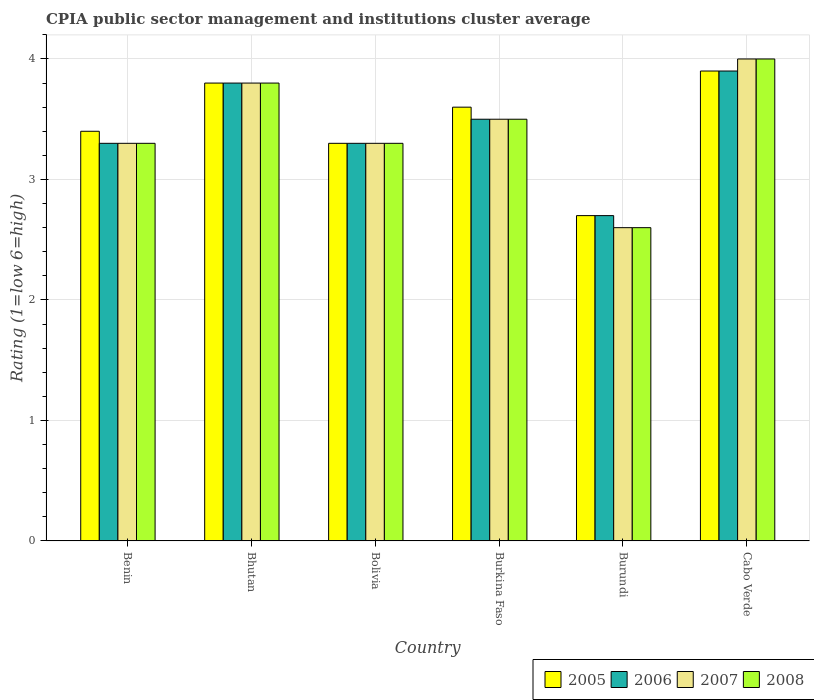How many groups of bars are there?
Provide a succinct answer. 6. Are the number of bars on each tick of the X-axis equal?
Provide a succinct answer. Yes. How many bars are there on the 3rd tick from the right?
Your answer should be compact. 4. What is the label of the 6th group of bars from the left?
Ensure brevity in your answer.  Cabo Verde. In how many cases, is the number of bars for a given country not equal to the number of legend labels?
Provide a short and direct response. 0. What is the CPIA rating in 2005 in Bhutan?
Keep it short and to the point. 3.8. Across all countries, what is the maximum CPIA rating in 2005?
Provide a succinct answer. 3.9. Across all countries, what is the minimum CPIA rating in 2008?
Your answer should be compact. 2.6. In which country was the CPIA rating in 2006 maximum?
Provide a short and direct response. Cabo Verde. In which country was the CPIA rating in 2007 minimum?
Make the answer very short. Burundi. What is the difference between the CPIA rating in 2007 in Burkina Faso and that in Burundi?
Ensure brevity in your answer.  0.9. What is the average CPIA rating in 2006 per country?
Offer a very short reply. 3.42. What is the difference between the CPIA rating of/in 2005 and CPIA rating of/in 2008 in Burundi?
Offer a very short reply. 0.1. In how many countries, is the CPIA rating in 2006 greater than 1.2?
Give a very brief answer. 6. What is the ratio of the CPIA rating in 2007 in Benin to that in Burundi?
Make the answer very short. 1.27. Is the CPIA rating in 2006 in Benin less than that in Burundi?
Provide a short and direct response. No. Is the difference between the CPIA rating in 2005 in Bolivia and Cabo Verde greater than the difference between the CPIA rating in 2008 in Bolivia and Cabo Verde?
Ensure brevity in your answer.  Yes. What is the difference between the highest and the second highest CPIA rating in 2005?
Give a very brief answer. -0.1. What is the difference between the highest and the lowest CPIA rating in 2005?
Make the answer very short. 1.2. In how many countries, is the CPIA rating in 2006 greater than the average CPIA rating in 2006 taken over all countries?
Offer a terse response. 3. What does the 1st bar from the left in Bhutan represents?
Keep it short and to the point. 2005. Is it the case that in every country, the sum of the CPIA rating in 2008 and CPIA rating in 2006 is greater than the CPIA rating in 2007?
Provide a succinct answer. Yes. Are all the bars in the graph horizontal?
Ensure brevity in your answer.  No. How many countries are there in the graph?
Your answer should be compact. 6. Are the values on the major ticks of Y-axis written in scientific E-notation?
Ensure brevity in your answer.  No. How many legend labels are there?
Offer a very short reply. 4. How are the legend labels stacked?
Give a very brief answer. Horizontal. What is the title of the graph?
Ensure brevity in your answer.  CPIA public sector management and institutions cluster average. What is the label or title of the Y-axis?
Provide a short and direct response. Rating (1=low 6=high). What is the Rating (1=low 6=high) in 2008 in Benin?
Your answer should be compact. 3.3. What is the Rating (1=low 6=high) of 2005 in Bhutan?
Give a very brief answer. 3.8. What is the Rating (1=low 6=high) of 2006 in Bolivia?
Provide a succinct answer. 3.3. What is the Rating (1=low 6=high) in 2007 in Bolivia?
Provide a succinct answer. 3.3. What is the Rating (1=low 6=high) in 2008 in Bolivia?
Give a very brief answer. 3.3. What is the Rating (1=low 6=high) of 2005 in Burundi?
Make the answer very short. 2.7. What is the Rating (1=low 6=high) of 2006 in Burundi?
Make the answer very short. 2.7. Across all countries, what is the maximum Rating (1=low 6=high) of 2005?
Offer a terse response. 3.9. Across all countries, what is the maximum Rating (1=low 6=high) in 2006?
Offer a terse response. 3.9. Across all countries, what is the maximum Rating (1=low 6=high) of 2008?
Offer a terse response. 4. What is the total Rating (1=low 6=high) in 2005 in the graph?
Keep it short and to the point. 20.7. What is the total Rating (1=low 6=high) of 2006 in the graph?
Keep it short and to the point. 20.5. What is the total Rating (1=low 6=high) in 2008 in the graph?
Your answer should be compact. 20.5. What is the difference between the Rating (1=low 6=high) of 2005 in Benin and that in Bhutan?
Your answer should be very brief. -0.4. What is the difference between the Rating (1=low 6=high) in 2006 in Benin and that in Bhutan?
Your answer should be compact. -0.5. What is the difference between the Rating (1=low 6=high) of 2007 in Benin and that in Bhutan?
Offer a very short reply. -0.5. What is the difference between the Rating (1=low 6=high) of 2008 in Benin and that in Bhutan?
Ensure brevity in your answer.  -0.5. What is the difference between the Rating (1=low 6=high) in 2008 in Benin and that in Bolivia?
Ensure brevity in your answer.  0. What is the difference between the Rating (1=low 6=high) of 2006 in Benin and that in Burkina Faso?
Provide a succinct answer. -0.2. What is the difference between the Rating (1=low 6=high) in 2006 in Benin and that in Burundi?
Make the answer very short. 0.6. What is the difference between the Rating (1=low 6=high) of 2008 in Benin and that in Burundi?
Provide a short and direct response. 0.7. What is the difference between the Rating (1=low 6=high) of 2005 in Benin and that in Cabo Verde?
Your answer should be compact. -0.5. What is the difference between the Rating (1=low 6=high) in 2006 in Benin and that in Cabo Verde?
Offer a very short reply. -0.6. What is the difference between the Rating (1=low 6=high) of 2007 in Benin and that in Cabo Verde?
Give a very brief answer. -0.7. What is the difference between the Rating (1=low 6=high) of 2006 in Bhutan and that in Bolivia?
Ensure brevity in your answer.  0.5. What is the difference between the Rating (1=low 6=high) in 2007 in Bhutan and that in Bolivia?
Provide a succinct answer. 0.5. What is the difference between the Rating (1=low 6=high) of 2005 in Bhutan and that in Burkina Faso?
Keep it short and to the point. 0.2. What is the difference between the Rating (1=low 6=high) in 2005 in Bhutan and that in Burundi?
Keep it short and to the point. 1.1. What is the difference between the Rating (1=low 6=high) in 2006 in Bhutan and that in Burundi?
Your response must be concise. 1.1. What is the difference between the Rating (1=low 6=high) of 2008 in Bhutan and that in Burundi?
Keep it short and to the point. 1.2. What is the difference between the Rating (1=low 6=high) of 2007 in Bolivia and that in Burundi?
Offer a terse response. 0.7. What is the difference between the Rating (1=low 6=high) in 2006 in Bolivia and that in Cabo Verde?
Give a very brief answer. -0.6. What is the difference between the Rating (1=low 6=high) of 2008 in Bolivia and that in Cabo Verde?
Offer a very short reply. -0.7. What is the difference between the Rating (1=low 6=high) of 2005 in Burkina Faso and that in Burundi?
Your answer should be compact. 0.9. What is the difference between the Rating (1=low 6=high) in 2008 in Burkina Faso and that in Burundi?
Keep it short and to the point. 0.9. What is the difference between the Rating (1=low 6=high) in 2005 in Burkina Faso and that in Cabo Verde?
Make the answer very short. -0.3. What is the difference between the Rating (1=low 6=high) of 2007 in Burkina Faso and that in Cabo Verde?
Offer a terse response. -0.5. What is the difference between the Rating (1=low 6=high) in 2008 in Burkina Faso and that in Cabo Verde?
Offer a terse response. -0.5. What is the difference between the Rating (1=low 6=high) in 2006 in Burundi and that in Cabo Verde?
Ensure brevity in your answer.  -1.2. What is the difference between the Rating (1=low 6=high) of 2008 in Burundi and that in Cabo Verde?
Offer a terse response. -1.4. What is the difference between the Rating (1=low 6=high) of 2005 in Benin and the Rating (1=low 6=high) of 2006 in Bhutan?
Give a very brief answer. -0.4. What is the difference between the Rating (1=low 6=high) of 2005 in Benin and the Rating (1=low 6=high) of 2007 in Bhutan?
Offer a terse response. -0.4. What is the difference between the Rating (1=low 6=high) in 2006 in Benin and the Rating (1=low 6=high) in 2007 in Bhutan?
Offer a very short reply. -0.5. What is the difference between the Rating (1=low 6=high) of 2006 in Benin and the Rating (1=low 6=high) of 2008 in Bhutan?
Keep it short and to the point. -0.5. What is the difference between the Rating (1=low 6=high) in 2007 in Benin and the Rating (1=low 6=high) in 2008 in Bhutan?
Give a very brief answer. -0.5. What is the difference between the Rating (1=low 6=high) in 2006 in Benin and the Rating (1=low 6=high) in 2007 in Bolivia?
Make the answer very short. 0. What is the difference between the Rating (1=low 6=high) of 2006 in Benin and the Rating (1=low 6=high) of 2008 in Bolivia?
Keep it short and to the point. 0. What is the difference between the Rating (1=low 6=high) in 2007 in Benin and the Rating (1=low 6=high) in 2008 in Bolivia?
Keep it short and to the point. 0. What is the difference between the Rating (1=low 6=high) of 2005 in Benin and the Rating (1=low 6=high) of 2006 in Burkina Faso?
Keep it short and to the point. -0.1. What is the difference between the Rating (1=low 6=high) in 2005 in Benin and the Rating (1=low 6=high) in 2007 in Burkina Faso?
Your answer should be very brief. -0.1. What is the difference between the Rating (1=low 6=high) in 2005 in Benin and the Rating (1=low 6=high) in 2008 in Burkina Faso?
Your answer should be compact. -0.1. What is the difference between the Rating (1=low 6=high) in 2005 in Benin and the Rating (1=low 6=high) in 2007 in Burundi?
Make the answer very short. 0.8. What is the difference between the Rating (1=low 6=high) in 2005 in Benin and the Rating (1=low 6=high) in 2008 in Burundi?
Your answer should be compact. 0.8. What is the difference between the Rating (1=low 6=high) in 2007 in Benin and the Rating (1=low 6=high) in 2008 in Burundi?
Your response must be concise. 0.7. What is the difference between the Rating (1=low 6=high) in 2006 in Benin and the Rating (1=low 6=high) in 2008 in Cabo Verde?
Your answer should be compact. -0.7. What is the difference between the Rating (1=low 6=high) of 2005 in Bhutan and the Rating (1=low 6=high) of 2006 in Bolivia?
Give a very brief answer. 0.5. What is the difference between the Rating (1=low 6=high) in 2005 in Bhutan and the Rating (1=low 6=high) in 2008 in Bolivia?
Your response must be concise. 0.5. What is the difference between the Rating (1=low 6=high) of 2006 in Bhutan and the Rating (1=low 6=high) of 2008 in Bolivia?
Keep it short and to the point. 0.5. What is the difference between the Rating (1=low 6=high) in 2005 in Bhutan and the Rating (1=low 6=high) in 2007 in Burkina Faso?
Your answer should be very brief. 0.3. What is the difference between the Rating (1=low 6=high) of 2005 in Bhutan and the Rating (1=low 6=high) of 2007 in Burundi?
Provide a short and direct response. 1.2. What is the difference between the Rating (1=low 6=high) of 2005 in Bhutan and the Rating (1=low 6=high) of 2008 in Burundi?
Give a very brief answer. 1.2. What is the difference between the Rating (1=low 6=high) of 2007 in Bhutan and the Rating (1=low 6=high) of 2008 in Burundi?
Offer a very short reply. 1.2. What is the difference between the Rating (1=low 6=high) of 2005 in Bhutan and the Rating (1=low 6=high) of 2008 in Cabo Verde?
Make the answer very short. -0.2. What is the difference between the Rating (1=low 6=high) in 2006 in Bhutan and the Rating (1=low 6=high) in 2007 in Cabo Verde?
Make the answer very short. -0.2. What is the difference between the Rating (1=low 6=high) in 2006 in Bolivia and the Rating (1=low 6=high) in 2007 in Burkina Faso?
Provide a succinct answer. -0.2. What is the difference between the Rating (1=low 6=high) in 2005 in Bolivia and the Rating (1=low 6=high) in 2007 in Burundi?
Make the answer very short. 0.7. What is the difference between the Rating (1=low 6=high) in 2006 in Bolivia and the Rating (1=low 6=high) in 2007 in Burundi?
Make the answer very short. 0.7. What is the difference between the Rating (1=low 6=high) in 2007 in Bolivia and the Rating (1=low 6=high) in 2008 in Burundi?
Offer a very short reply. 0.7. What is the difference between the Rating (1=low 6=high) in 2005 in Bolivia and the Rating (1=low 6=high) in 2008 in Cabo Verde?
Give a very brief answer. -0.7. What is the difference between the Rating (1=low 6=high) in 2007 in Bolivia and the Rating (1=low 6=high) in 2008 in Cabo Verde?
Make the answer very short. -0.7. What is the difference between the Rating (1=low 6=high) in 2006 in Burkina Faso and the Rating (1=low 6=high) in 2007 in Burundi?
Your answer should be compact. 0.9. What is the difference between the Rating (1=low 6=high) in 2006 in Burkina Faso and the Rating (1=low 6=high) in 2008 in Burundi?
Make the answer very short. 0.9. What is the difference between the Rating (1=low 6=high) of 2007 in Burkina Faso and the Rating (1=low 6=high) of 2008 in Burundi?
Provide a short and direct response. 0.9. What is the difference between the Rating (1=low 6=high) in 2005 in Burkina Faso and the Rating (1=low 6=high) in 2007 in Cabo Verde?
Give a very brief answer. -0.4. What is the difference between the Rating (1=low 6=high) of 2006 in Burkina Faso and the Rating (1=low 6=high) of 2008 in Cabo Verde?
Your answer should be very brief. -0.5. What is the difference between the Rating (1=low 6=high) in 2007 in Burkina Faso and the Rating (1=low 6=high) in 2008 in Cabo Verde?
Ensure brevity in your answer.  -0.5. What is the difference between the Rating (1=low 6=high) of 2005 in Burundi and the Rating (1=low 6=high) of 2006 in Cabo Verde?
Provide a short and direct response. -1.2. What is the difference between the Rating (1=low 6=high) of 2005 in Burundi and the Rating (1=low 6=high) of 2007 in Cabo Verde?
Keep it short and to the point. -1.3. What is the difference between the Rating (1=low 6=high) in 2005 in Burundi and the Rating (1=low 6=high) in 2008 in Cabo Verde?
Give a very brief answer. -1.3. What is the difference between the Rating (1=low 6=high) of 2006 in Burundi and the Rating (1=low 6=high) of 2007 in Cabo Verde?
Your answer should be compact. -1.3. What is the difference between the Rating (1=low 6=high) in 2007 in Burundi and the Rating (1=low 6=high) in 2008 in Cabo Verde?
Keep it short and to the point. -1.4. What is the average Rating (1=low 6=high) in 2005 per country?
Offer a terse response. 3.45. What is the average Rating (1=low 6=high) of 2006 per country?
Ensure brevity in your answer.  3.42. What is the average Rating (1=low 6=high) of 2007 per country?
Ensure brevity in your answer.  3.42. What is the average Rating (1=low 6=high) in 2008 per country?
Offer a very short reply. 3.42. What is the difference between the Rating (1=low 6=high) of 2005 and Rating (1=low 6=high) of 2006 in Benin?
Give a very brief answer. 0.1. What is the difference between the Rating (1=low 6=high) in 2005 and Rating (1=low 6=high) in 2007 in Benin?
Your answer should be very brief. 0.1. What is the difference between the Rating (1=low 6=high) of 2006 and Rating (1=low 6=high) of 2007 in Benin?
Give a very brief answer. 0. What is the difference between the Rating (1=low 6=high) of 2007 and Rating (1=low 6=high) of 2008 in Benin?
Offer a terse response. 0. What is the difference between the Rating (1=low 6=high) of 2006 and Rating (1=low 6=high) of 2008 in Bhutan?
Give a very brief answer. 0. What is the difference between the Rating (1=low 6=high) in 2005 and Rating (1=low 6=high) in 2007 in Bolivia?
Ensure brevity in your answer.  0. What is the difference between the Rating (1=low 6=high) of 2006 and Rating (1=low 6=high) of 2008 in Bolivia?
Your answer should be compact. 0. What is the difference between the Rating (1=low 6=high) of 2007 and Rating (1=low 6=high) of 2008 in Bolivia?
Provide a short and direct response. 0. What is the difference between the Rating (1=low 6=high) in 2006 and Rating (1=low 6=high) in 2007 in Burkina Faso?
Your answer should be very brief. 0. What is the difference between the Rating (1=low 6=high) of 2006 and Rating (1=low 6=high) of 2008 in Burkina Faso?
Offer a terse response. 0. What is the difference between the Rating (1=low 6=high) in 2006 and Rating (1=low 6=high) in 2007 in Burundi?
Provide a succinct answer. 0.1. What is the difference between the Rating (1=low 6=high) of 2007 and Rating (1=low 6=high) of 2008 in Burundi?
Offer a terse response. 0. What is the difference between the Rating (1=low 6=high) in 2005 and Rating (1=low 6=high) in 2006 in Cabo Verde?
Your answer should be compact. 0. What is the difference between the Rating (1=low 6=high) in 2005 and Rating (1=low 6=high) in 2008 in Cabo Verde?
Your response must be concise. -0.1. What is the difference between the Rating (1=low 6=high) of 2006 and Rating (1=low 6=high) of 2008 in Cabo Verde?
Your response must be concise. -0.1. What is the difference between the Rating (1=low 6=high) in 2007 and Rating (1=low 6=high) in 2008 in Cabo Verde?
Provide a succinct answer. 0. What is the ratio of the Rating (1=low 6=high) of 2005 in Benin to that in Bhutan?
Offer a very short reply. 0.89. What is the ratio of the Rating (1=low 6=high) in 2006 in Benin to that in Bhutan?
Make the answer very short. 0.87. What is the ratio of the Rating (1=low 6=high) in 2007 in Benin to that in Bhutan?
Give a very brief answer. 0.87. What is the ratio of the Rating (1=low 6=high) of 2008 in Benin to that in Bhutan?
Provide a short and direct response. 0.87. What is the ratio of the Rating (1=low 6=high) in 2005 in Benin to that in Bolivia?
Ensure brevity in your answer.  1.03. What is the ratio of the Rating (1=low 6=high) in 2006 in Benin to that in Burkina Faso?
Ensure brevity in your answer.  0.94. What is the ratio of the Rating (1=low 6=high) in 2007 in Benin to that in Burkina Faso?
Offer a very short reply. 0.94. What is the ratio of the Rating (1=low 6=high) in 2008 in Benin to that in Burkina Faso?
Provide a succinct answer. 0.94. What is the ratio of the Rating (1=low 6=high) of 2005 in Benin to that in Burundi?
Offer a very short reply. 1.26. What is the ratio of the Rating (1=low 6=high) of 2006 in Benin to that in Burundi?
Ensure brevity in your answer.  1.22. What is the ratio of the Rating (1=low 6=high) in 2007 in Benin to that in Burundi?
Offer a terse response. 1.27. What is the ratio of the Rating (1=low 6=high) of 2008 in Benin to that in Burundi?
Offer a terse response. 1.27. What is the ratio of the Rating (1=low 6=high) in 2005 in Benin to that in Cabo Verde?
Your response must be concise. 0.87. What is the ratio of the Rating (1=low 6=high) in 2006 in Benin to that in Cabo Verde?
Offer a very short reply. 0.85. What is the ratio of the Rating (1=low 6=high) of 2007 in Benin to that in Cabo Verde?
Your answer should be compact. 0.82. What is the ratio of the Rating (1=low 6=high) in 2008 in Benin to that in Cabo Verde?
Your answer should be very brief. 0.82. What is the ratio of the Rating (1=low 6=high) of 2005 in Bhutan to that in Bolivia?
Give a very brief answer. 1.15. What is the ratio of the Rating (1=low 6=high) in 2006 in Bhutan to that in Bolivia?
Give a very brief answer. 1.15. What is the ratio of the Rating (1=low 6=high) in 2007 in Bhutan to that in Bolivia?
Provide a short and direct response. 1.15. What is the ratio of the Rating (1=low 6=high) in 2008 in Bhutan to that in Bolivia?
Keep it short and to the point. 1.15. What is the ratio of the Rating (1=low 6=high) in 2005 in Bhutan to that in Burkina Faso?
Offer a terse response. 1.06. What is the ratio of the Rating (1=low 6=high) of 2006 in Bhutan to that in Burkina Faso?
Provide a succinct answer. 1.09. What is the ratio of the Rating (1=low 6=high) in 2007 in Bhutan to that in Burkina Faso?
Keep it short and to the point. 1.09. What is the ratio of the Rating (1=low 6=high) of 2008 in Bhutan to that in Burkina Faso?
Your answer should be very brief. 1.09. What is the ratio of the Rating (1=low 6=high) of 2005 in Bhutan to that in Burundi?
Provide a succinct answer. 1.41. What is the ratio of the Rating (1=low 6=high) in 2006 in Bhutan to that in Burundi?
Make the answer very short. 1.41. What is the ratio of the Rating (1=low 6=high) in 2007 in Bhutan to that in Burundi?
Your answer should be very brief. 1.46. What is the ratio of the Rating (1=low 6=high) of 2008 in Bhutan to that in Burundi?
Offer a terse response. 1.46. What is the ratio of the Rating (1=low 6=high) of 2005 in Bhutan to that in Cabo Verde?
Your answer should be compact. 0.97. What is the ratio of the Rating (1=low 6=high) in 2006 in Bhutan to that in Cabo Verde?
Make the answer very short. 0.97. What is the ratio of the Rating (1=low 6=high) of 2007 in Bhutan to that in Cabo Verde?
Your answer should be very brief. 0.95. What is the ratio of the Rating (1=low 6=high) of 2008 in Bhutan to that in Cabo Verde?
Give a very brief answer. 0.95. What is the ratio of the Rating (1=low 6=high) of 2005 in Bolivia to that in Burkina Faso?
Provide a short and direct response. 0.92. What is the ratio of the Rating (1=low 6=high) in 2006 in Bolivia to that in Burkina Faso?
Your answer should be compact. 0.94. What is the ratio of the Rating (1=low 6=high) in 2007 in Bolivia to that in Burkina Faso?
Provide a succinct answer. 0.94. What is the ratio of the Rating (1=low 6=high) in 2008 in Bolivia to that in Burkina Faso?
Your answer should be compact. 0.94. What is the ratio of the Rating (1=low 6=high) in 2005 in Bolivia to that in Burundi?
Your response must be concise. 1.22. What is the ratio of the Rating (1=low 6=high) in 2006 in Bolivia to that in Burundi?
Give a very brief answer. 1.22. What is the ratio of the Rating (1=low 6=high) in 2007 in Bolivia to that in Burundi?
Keep it short and to the point. 1.27. What is the ratio of the Rating (1=low 6=high) in 2008 in Bolivia to that in Burundi?
Give a very brief answer. 1.27. What is the ratio of the Rating (1=low 6=high) in 2005 in Bolivia to that in Cabo Verde?
Provide a short and direct response. 0.85. What is the ratio of the Rating (1=low 6=high) of 2006 in Bolivia to that in Cabo Verde?
Keep it short and to the point. 0.85. What is the ratio of the Rating (1=low 6=high) of 2007 in Bolivia to that in Cabo Verde?
Offer a terse response. 0.82. What is the ratio of the Rating (1=low 6=high) in 2008 in Bolivia to that in Cabo Verde?
Keep it short and to the point. 0.82. What is the ratio of the Rating (1=low 6=high) in 2005 in Burkina Faso to that in Burundi?
Provide a succinct answer. 1.33. What is the ratio of the Rating (1=low 6=high) in 2006 in Burkina Faso to that in Burundi?
Ensure brevity in your answer.  1.3. What is the ratio of the Rating (1=low 6=high) of 2007 in Burkina Faso to that in Burundi?
Your response must be concise. 1.35. What is the ratio of the Rating (1=low 6=high) of 2008 in Burkina Faso to that in Burundi?
Provide a succinct answer. 1.35. What is the ratio of the Rating (1=low 6=high) in 2005 in Burkina Faso to that in Cabo Verde?
Provide a succinct answer. 0.92. What is the ratio of the Rating (1=low 6=high) of 2006 in Burkina Faso to that in Cabo Verde?
Keep it short and to the point. 0.9. What is the ratio of the Rating (1=low 6=high) in 2008 in Burkina Faso to that in Cabo Verde?
Your response must be concise. 0.88. What is the ratio of the Rating (1=low 6=high) of 2005 in Burundi to that in Cabo Verde?
Provide a succinct answer. 0.69. What is the ratio of the Rating (1=low 6=high) in 2006 in Burundi to that in Cabo Verde?
Ensure brevity in your answer.  0.69. What is the ratio of the Rating (1=low 6=high) in 2007 in Burundi to that in Cabo Verde?
Your response must be concise. 0.65. What is the ratio of the Rating (1=low 6=high) in 2008 in Burundi to that in Cabo Verde?
Offer a terse response. 0.65. What is the difference between the highest and the second highest Rating (1=low 6=high) of 2008?
Offer a very short reply. 0.2. What is the difference between the highest and the lowest Rating (1=low 6=high) of 2006?
Make the answer very short. 1.2. What is the difference between the highest and the lowest Rating (1=low 6=high) in 2008?
Ensure brevity in your answer.  1.4. 